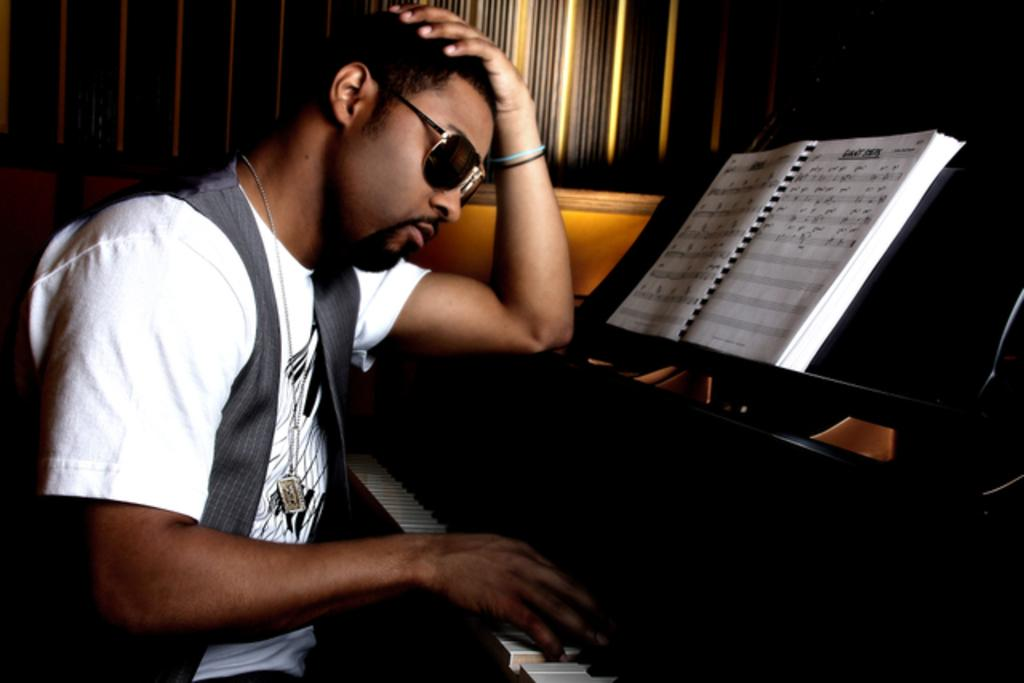What is the man in the image doing? The man is playing a piano. What can be seen on the man's face in the image? The man is wearing spectacles. What other object is present in the image besides the piano? There is a book in the image. What type of crate is being used to store the man's achievements in the image? There is no crate present in the image, nor is there any indication of the man's achievements. How many drawers are visible in the image? There are no drawers visible in the image. 